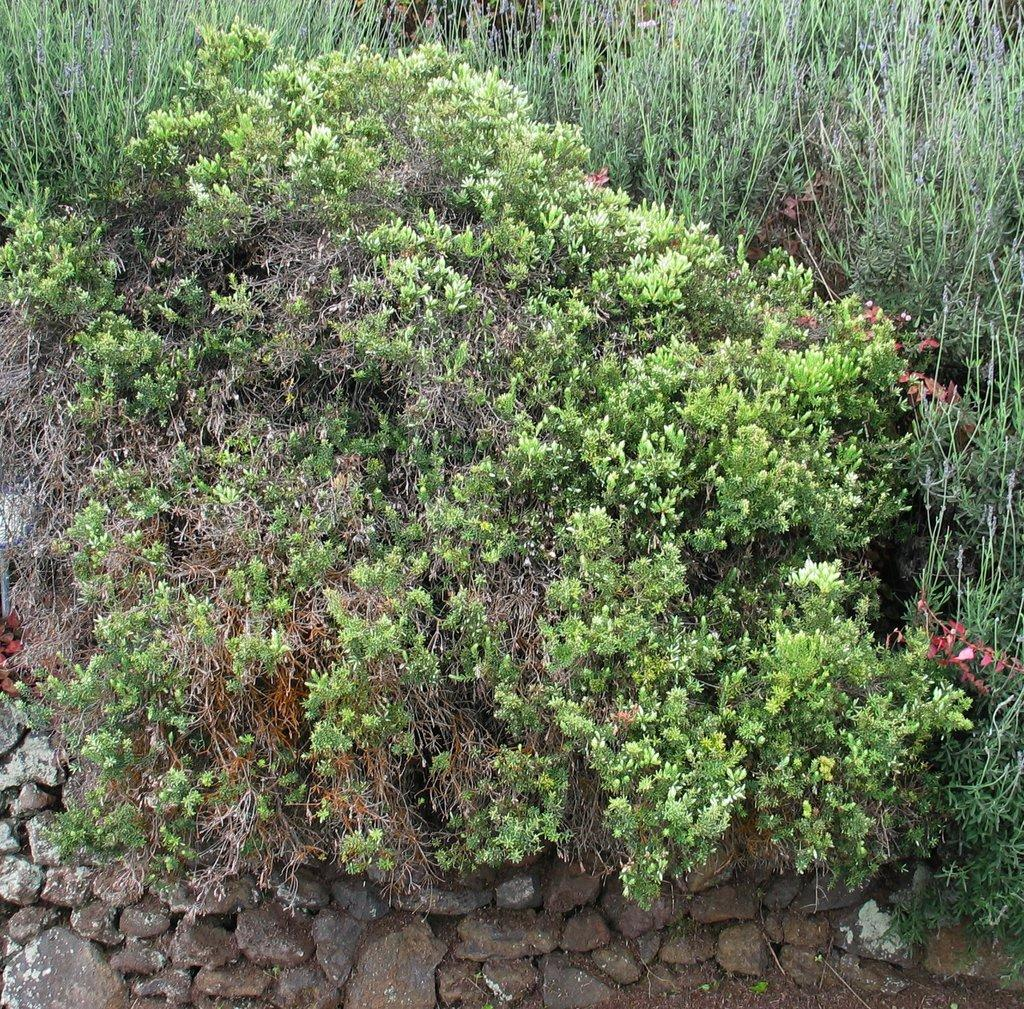What type of living organisms can be seen in the image? Plants can be seen in the image. What other objects are present in the image besides plants? There are stones in the image. What type of scarf is draped over the moon in the image? There is no moon or scarf present in the image; it only features plants and stones. 